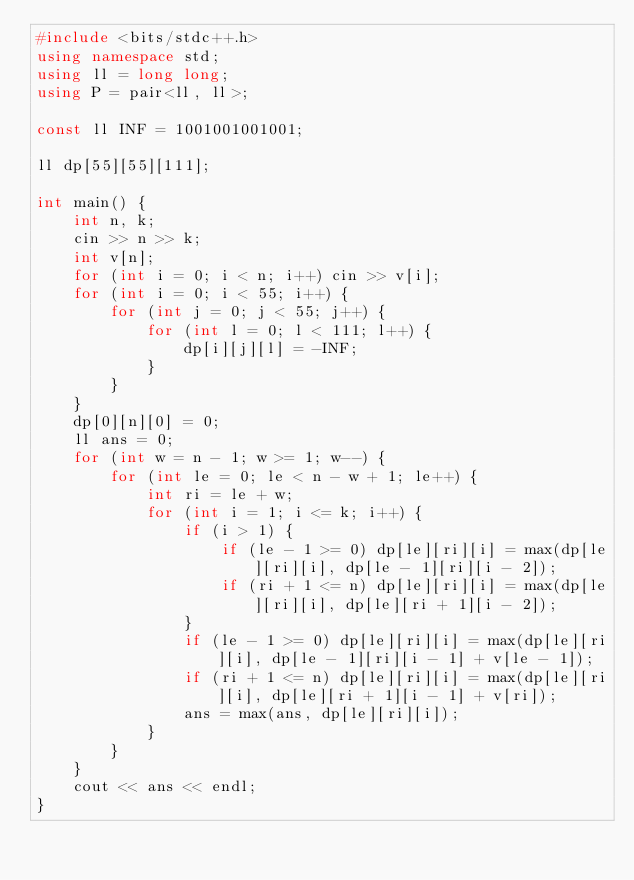Convert code to text. <code><loc_0><loc_0><loc_500><loc_500><_C++_>#include <bits/stdc++.h>
using namespace std;
using ll = long long;
using P = pair<ll, ll>;

const ll INF = 1001001001001;

ll dp[55][55][111];

int main() {
    int n, k;
    cin >> n >> k;
    int v[n];
    for (int i = 0; i < n; i++) cin >> v[i];
    for (int i = 0; i < 55; i++) {
        for (int j = 0; j < 55; j++) {
            for (int l = 0; l < 111; l++) {
                dp[i][j][l] = -INF;
            }
        }
    }
    dp[0][n][0] = 0;
    ll ans = 0;
    for (int w = n - 1; w >= 1; w--) {
        for (int le = 0; le < n - w + 1; le++) {
            int ri = le + w;
            for (int i = 1; i <= k; i++) {
                if (i > 1) {
                    if (le - 1 >= 0) dp[le][ri][i] = max(dp[le][ri][i], dp[le - 1][ri][i - 2]);
                    if (ri + 1 <= n) dp[le][ri][i] = max(dp[le][ri][i], dp[le][ri + 1][i - 2]);
                }
                if (le - 1 >= 0) dp[le][ri][i] = max(dp[le][ri][i], dp[le - 1][ri][i - 1] + v[le - 1]);
                if (ri + 1 <= n) dp[le][ri][i] = max(dp[le][ri][i], dp[le][ri + 1][i - 1] + v[ri]);
                ans = max(ans, dp[le][ri][i]);
            }
        }
    }
    cout << ans << endl;
}</code> 